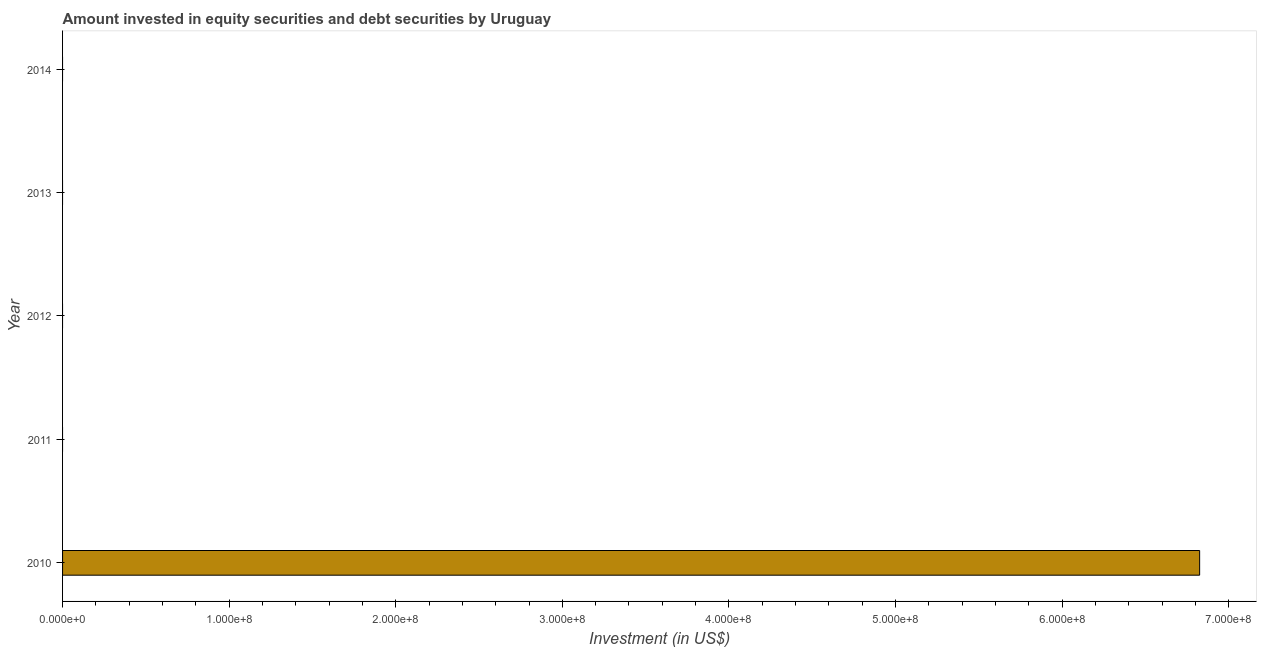Does the graph contain any zero values?
Ensure brevity in your answer.  Yes. What is the title of the graph?
Your answer should be compact. Amount invested in equity securities and debt securities by Uruguay. What is the label or title of the X-axis?
Give a very brief answer. Investment (in US$). What is the label or title of the Y-axis?
Offer a very short reply. Year. What is the portfolio investment in 2011?
Give a very brief answer. 0. Across all years, what is the maximum portfolio investment?
Make the answer very short. 6.83e+08. Across all years, what is the minimum portfolio investment?
Make the answer very short. 0. What is the sum of the portfolio investment?
Your answer should be very brief. 6.83e+08. What is the average portfolio investment per year?
Provide a short and direct response. 1.37e+08. In how many years, is the portfolio investment greater than 560000000 US$?
Make the answer very short. 1. What is the difference between the highest and the lowest portfolio investment?
Ensure brevity in your answer.  6.83e+08. In how many years, is the portfolio investment greater than the average portfolio investment taken over all years?
Your response must be concise. 1. How many bars are there?
Give a very brief answer. 1. Are all the bars in the graph horizontal?
Make the answer very short. Yes. Are the values on the major ticks of X-axis written in scientific E-notation?
Provide a succinct answer. Yes. What is the Investment (in US$) in 2010?
Make the answer very short. 6.83e+08. What is the Investment (in US$) in 2012?
Give a very brief answer. 0. What is the Investment (in US$) in 2013?
Make the answer very short. 0. 